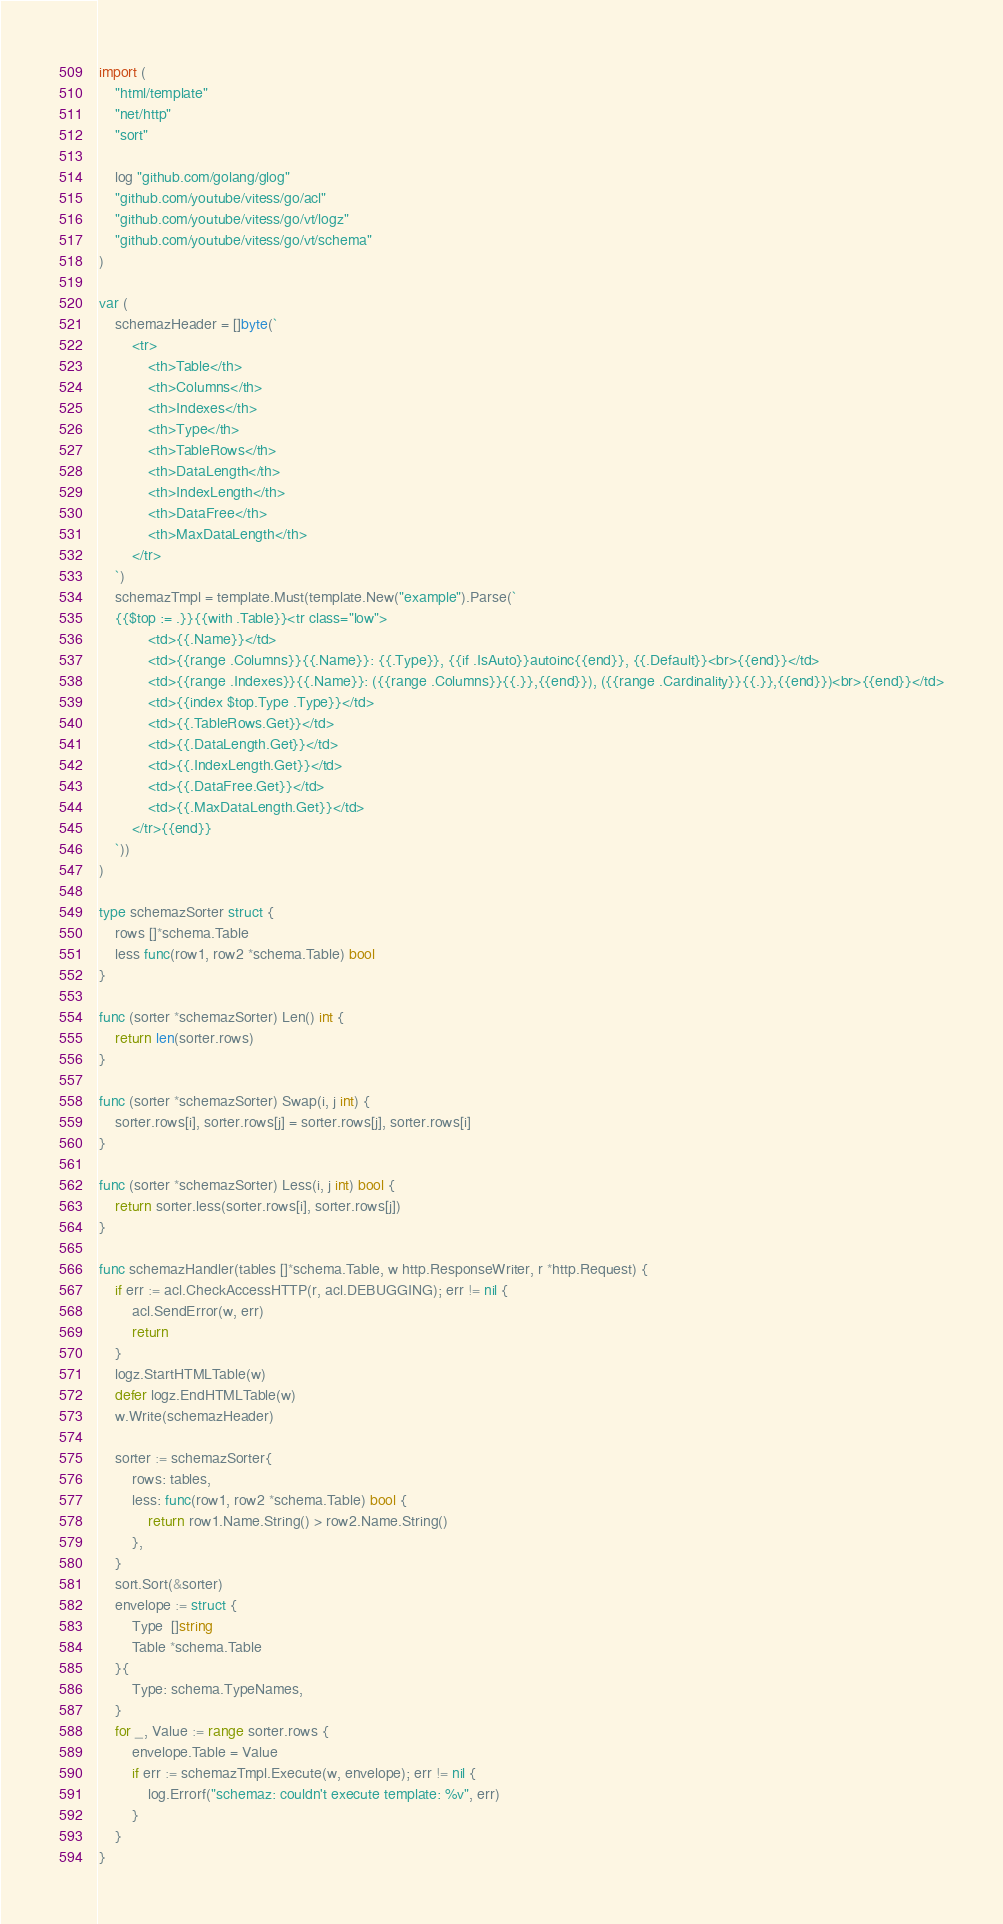Convert code to text. <code><loc_0><loc_0><loc_500><loc_500><_Go_>
import (
	"html/template"
	"net/http"
	"sort"

	log "github.com/golang/glog"
	"github.com/youtube/vitess/go/acl"
	"github.com/youtube/vitess/go/vt/logz"
	"github.com/youtube/vitess/go/vt/schema"
)

var (
	schemazHeader = []byte(`
		<tr>
			<th>Table</th>
			<th>Columns</th>
			<th>Indexes</th>
			<th>Type</th>
			<th>TableRows</th>
			<th>DataLength</th>
			<th>IndexLength</th>
			<th>DataFree</th>
			<th>MaxDataLength</th>
		</tr>
	`)
	schemazTmpl = template.Must(template.New("example").Parse(`
	{{$top := .}}{{with .Table}}<tr class="low">
			<td>{{.Name}}</td>
			<td>{{range .Columns}}{{.Name}}: {{.Type}}, {{if .IsAuto}}autoinc{{end}}, {{.Default}}<br>{{end}}</td>
			<td>{{range .Indexes}}{{.Name}}: ({{range .Columns}}{{.}},{{end}}), ({{range .Cardinality}}{{.}},{{end}})<br>{{end}}</td>
			<td>{{index $top.Type .Type}}</td>
			<td>{{.TableRows.Get}}</td>
			<td>{{.DataLength.Get}}</td>
			<td>{{.IndexLength.Get}}</td>
			<td>{{.DataFree.Get}}</td>
			<td>{{.MaxDataLength.Get}}</td>
		</tr>{{end}}
	`))
)

type schemazSorter struct {
	rows []*schema.Table
	less func(row1, row2 *schema.Table) bool
}

func (sorter *schemazSorter) Len() int {
	return len(sorter.rows)
}

func (sorter *schemazSorter) Swap(i, j int) {
	sorter.rows[i], sorter.rows[j] = sorter.rows[j], sorter.rows[i]
}

func (sorter *schemazSorter) Less(i, j int) bool {
	return sorter.less(sorter.rows[i], sorter.rows[j])
}

func schemazHandler(tables []*schema.Table, w http.ResponseWriter, r *http.Request) {
	if err := acl.CheckAccessHTTP(r, acl.DEBUGGING); err != nil {
		acl.SendError(w, err)
		return
	}
	logz.StartHTMLTable(w)
	defer logz.EndHTMLTable(w)
	w.Write(schemazHeader)

	sorter := schemazSorter{
		rows: tables,
		less: func(row1, row2 *schema.Table) bool {
			return row1.Name.String() > row2.Name.String()
		},
	}
	sort.Sort(&sorter)
	envelope := struct {
		Type  []string
		Table *schema.Table
	}{
		Type: schema.TypeNames,
	}
	for _, Value := range sorter.rows {
		envelope.Table = Value
		if err := schemazTmpl.Execute(w, envelope); err != nil {
			log.Errorf("schemaz: couldn't execute template: %v", err)
		}
	}
}
</code> 